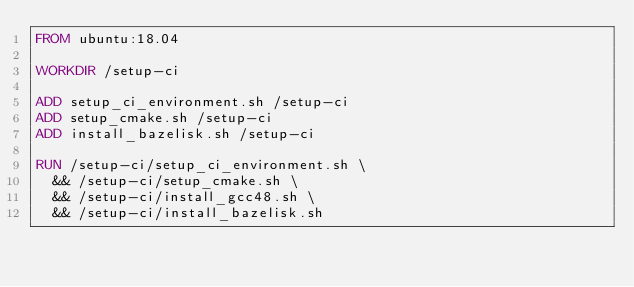<code> <loc_0><loc_0><loc_500><loc_500><_Dockerfile_>FROM ubuntu:18.04

WORKDIR /setup-ci

ADD setup_ci_environment.sh /setup-ci
ADD setup_cmake.sh /setup-ci
ADD install_bazelisk.sh /setup-ci

RUN /setup-ci/setup_ci_environment.sh \
  && /setup-ci/setup_cmake.sh \
  && /setup-ci/install_gcc48.sh \
  && /setup-ci/install_bazelisk.sh
</code> 